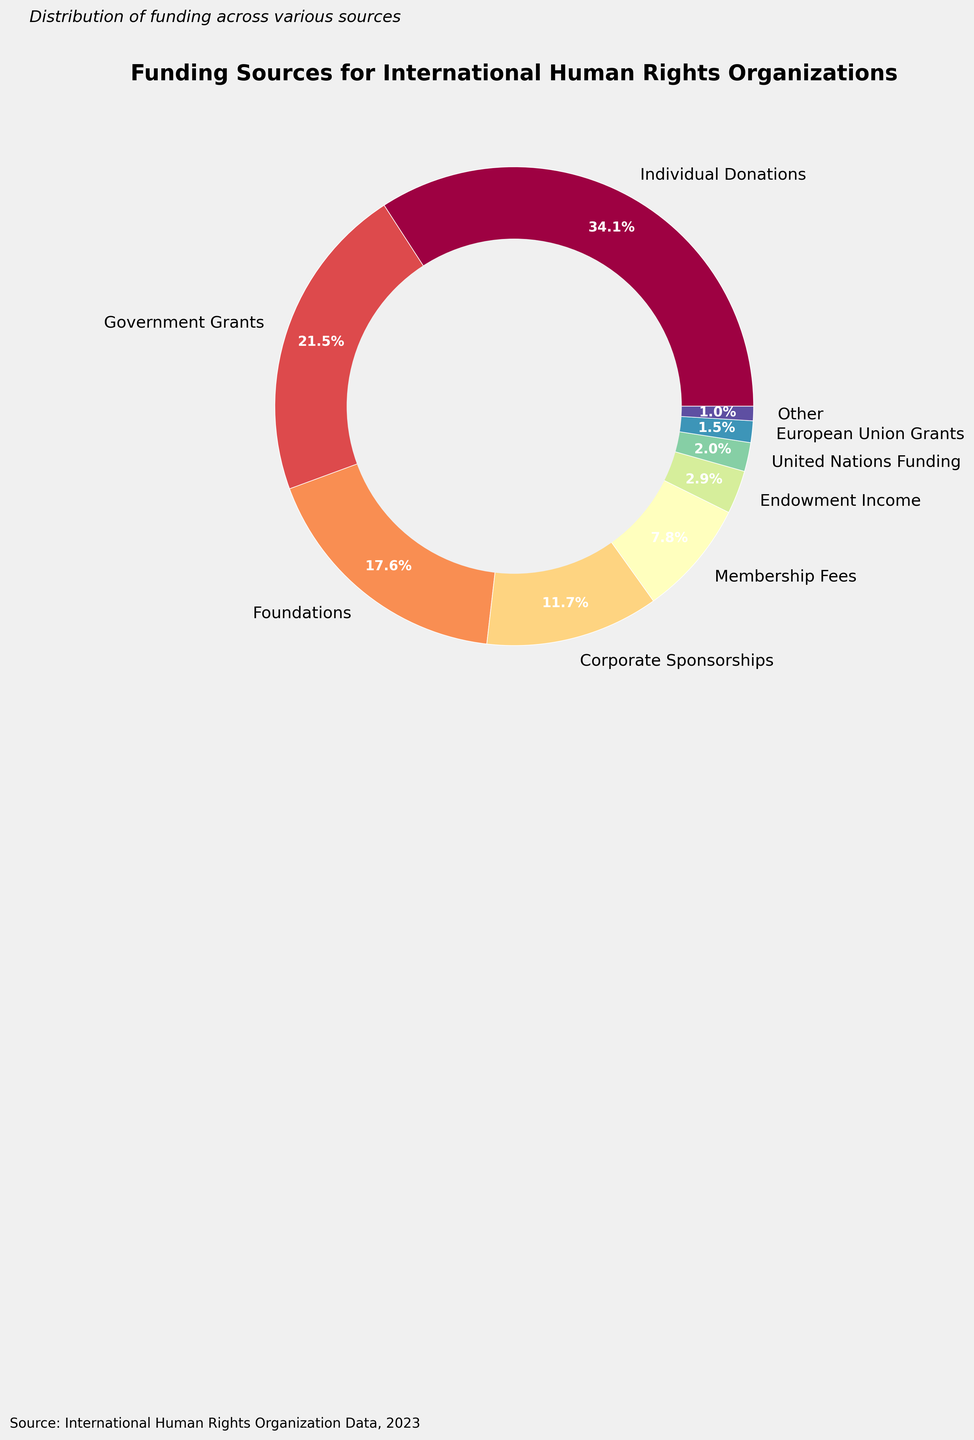Which funding source contributes the highest percentage to international human rights organizations? To answer this question, we look at the pie chart and identify the segment with the largest percentage. The largest percentage on the chart is for Individual Donations at 35%.
Answer: Individual Donations What is the combined percentage of funding from Government Grants and Foundations? To find the combined percentage, we add the percentage of Government Grants (22%) and Foundations (18%). 22 + 18 = 40
Answer: 40% Which funding sources contribute less than 5% individually? To find this, we identify the segments in the pie chart labeled with percentages less than 5%. The funding sources are Endowment Income (3%), United Nations Funding (2%), and European Union Grants (1.5%).
Answer: Endowment Income, United Nations Funding, European Union Grants How much more does Individual Donations contribute compared to Corporate Sponsorships? To answer this, we subtract the percentage of Corporate Sponsorships (12%) from Individual Donations (35%). 35 - 12 = 23
Answer: 23% What percentage does the "Other" category represent? The "Other" category is created to include the small percentages that weren't displayed individually. This includes Crowdfunding Campaigns (0.5%), In-Kind Donations (0.3%), and Legacy Gifts (0.2%). Adding these up gives us 0.5 + 0.3 + 0.2 = 1
Answer: 1% Is the percentage of Membership Fees larger than the percentage of Corporate Sponsorships? To answer this, compare the percentages of Membership Fees (8%) and Corporate Sponsorships (12%). 8% is smaller than 12%.
Answer: No What percentage of funding is obtained from sources other than Individual Donations, Government Grants, and Foundations? To calculate this, subtract the combined percentage of Individual Donations (35%), Government Grants (22%), and Foundations (18%) from 100%. 100 - (35 + 22 + 18) = 25
Answer: 25% Is the sum of percentages from Government Grants and Corporate Sponsorships greater than the sum from Foundations and Membership Fees? First, calculate the sums: Government Grants (22%) + Corporate Sponsorships (12%) = 34. Foundations (18%) + Membership Fees (8%) = 26. Compare 34 and 26. Yes, 34 is greater than 26.
Answer: Yes 